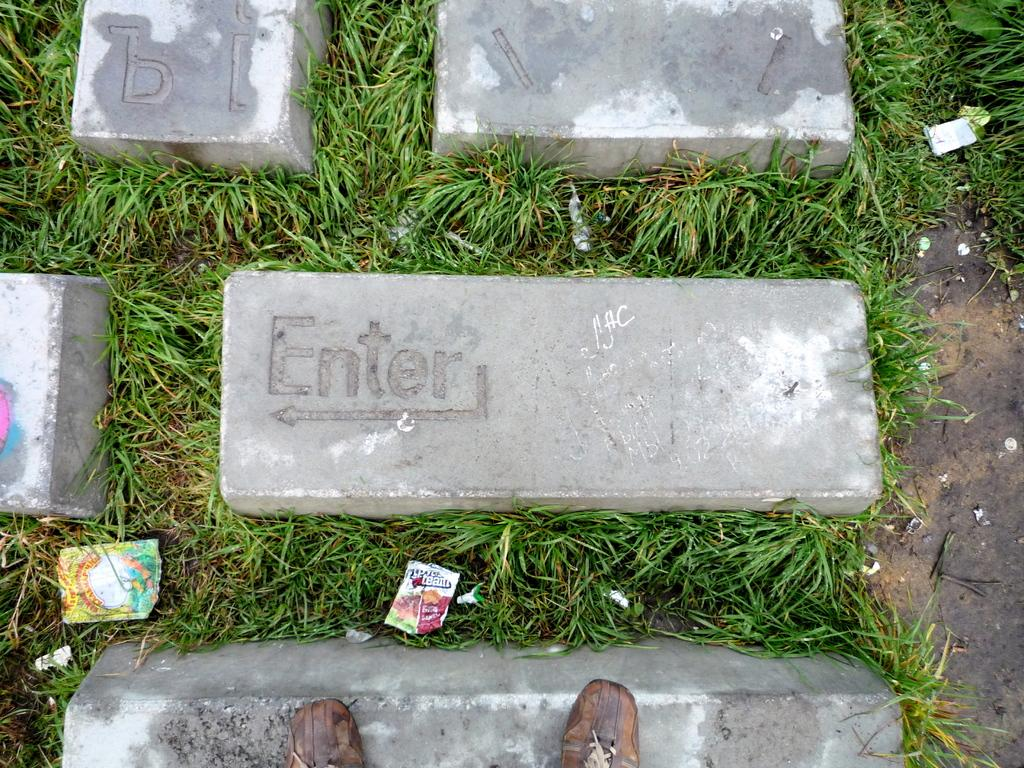What type of objects are on the ground in the image? There are stones on the ground in the image. What else can be seen in the image besides the stones? There are wrappers in the image. Which direction are the men walking in the image? There are no men present in the image, so it is not possible to determine the direction they might be walking. 